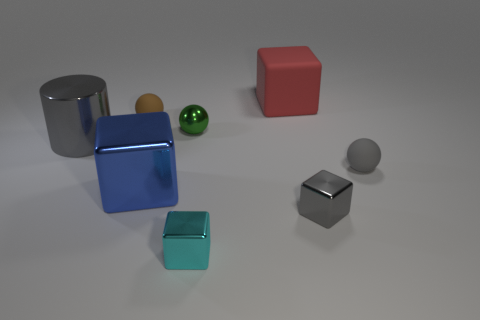Subtract all cyan cubes. How many cubes are left? 3 Subtract all green blocks. Subtract all gray cylinders. How many blocks are left? 4 Add 2 big green shiny spheres. How many objects exist? 10 Subtract all balls. How many objects are left? 5 Add 6 small gray shiny things. How many small gray shiny things are left? 7 Add 2 small brown rubber balls. How many small brown rubber balls exist? 3 Subtract 1 gray blocks. How many objects are left? 7 Subtract all small gray rubber objects. Subtract all red rubber objects. How many objects are left? 6 